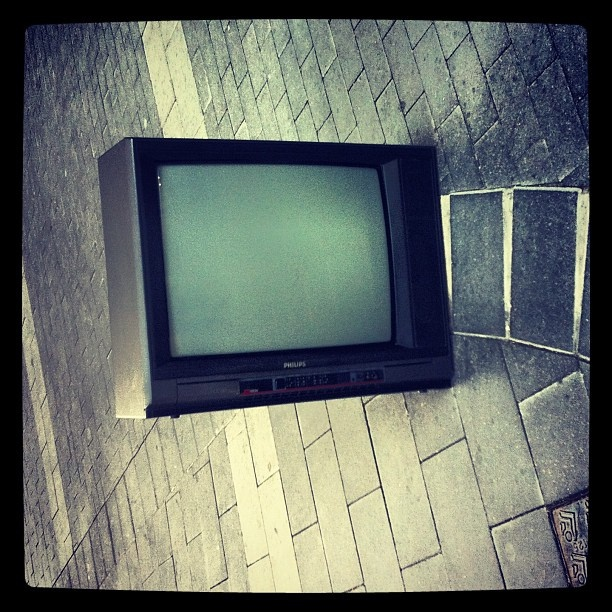Describe the objects in this image and their specific colors. I can see a tv in black, navy, teal, and darkgray tones in this image. 